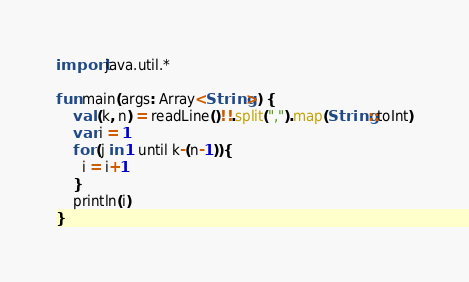Convert code to text. <code><loc_0><loc_0><loc_500><loc_500><_Kotlin_>import java.util.*

fun main(args: Array<String>) {
    val (k, n) = readLine()!!.split(",").map(String::toInt)
    var i = 1
    for (j in 1 until k-(n-1)){
      i = i+1
    }
    println(i)
}
</code> 